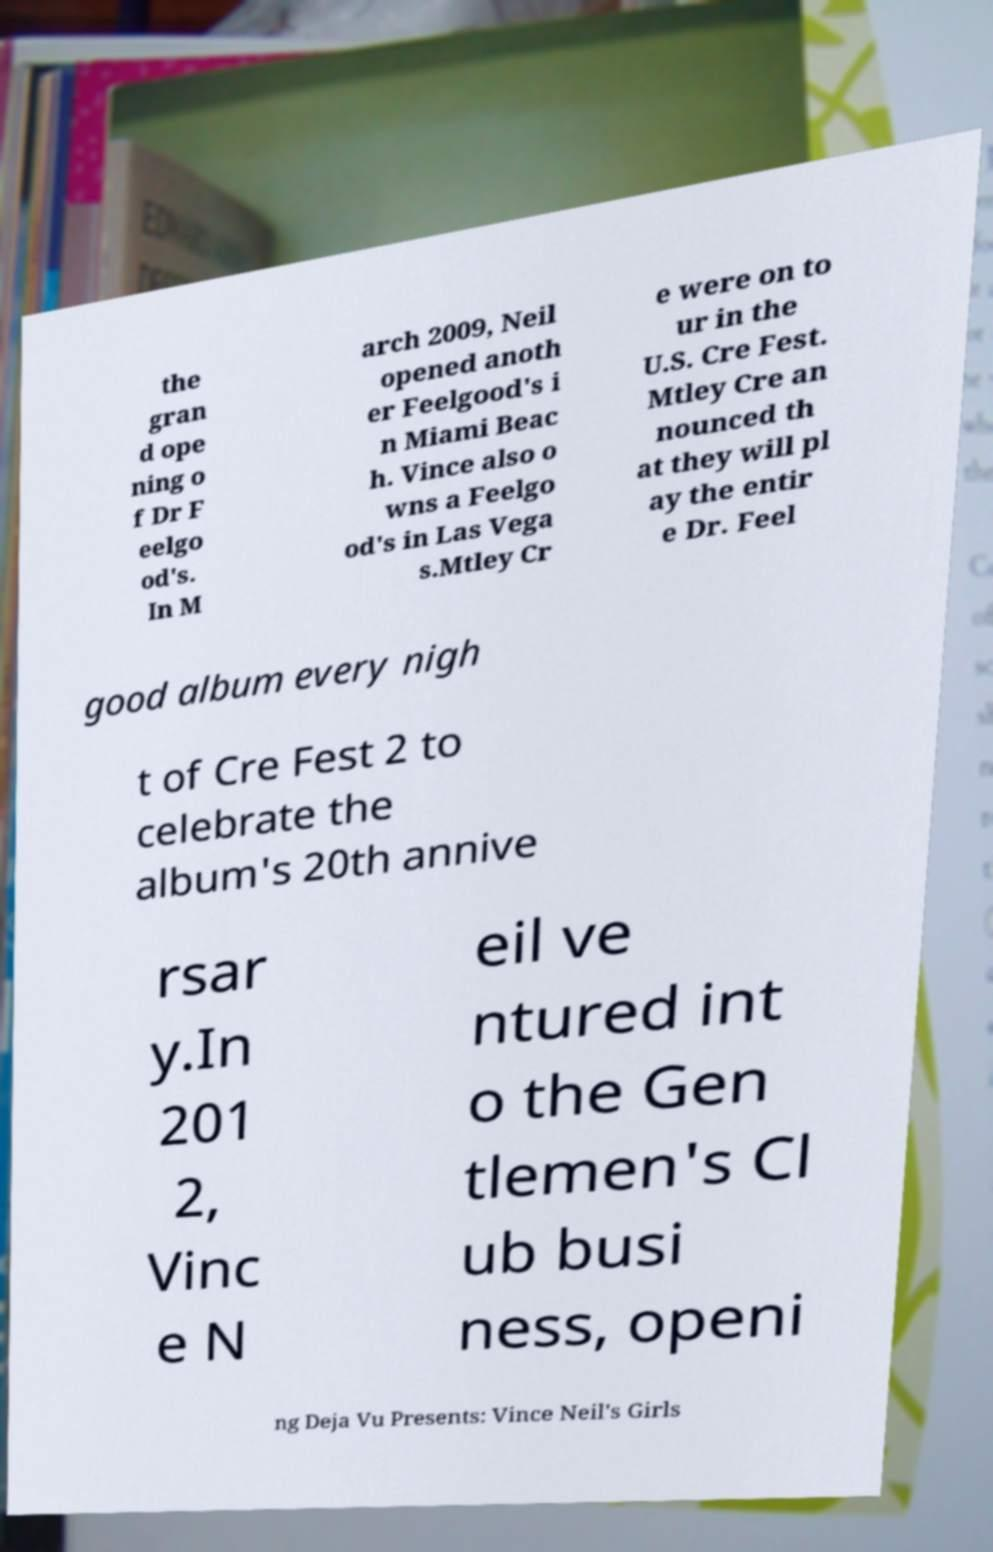Can you accurately transcribe the text from the provided image for me? the gran d ope ning o f Dr F eelgo od's. In M arch 2009, Neil opened anoth er Feelgood's i n Miami Beac h. Vince also o wns a Feelgo od's in Las Vega s.Mtley Cr e were on to ur in the U.S. Cre Fest. Mtley Cre an nounced th at they will pl ay the entir e Dr. Feel good album every nigh t of Cre Fest 2 to celebrate the album's 20th annive rsar y.In 201 2, Vinc e N eil ve ntured int o the Gen tlemen's Cl ub busi ness, openi ng Deja Vu Presents: Vince Neil's Girls 